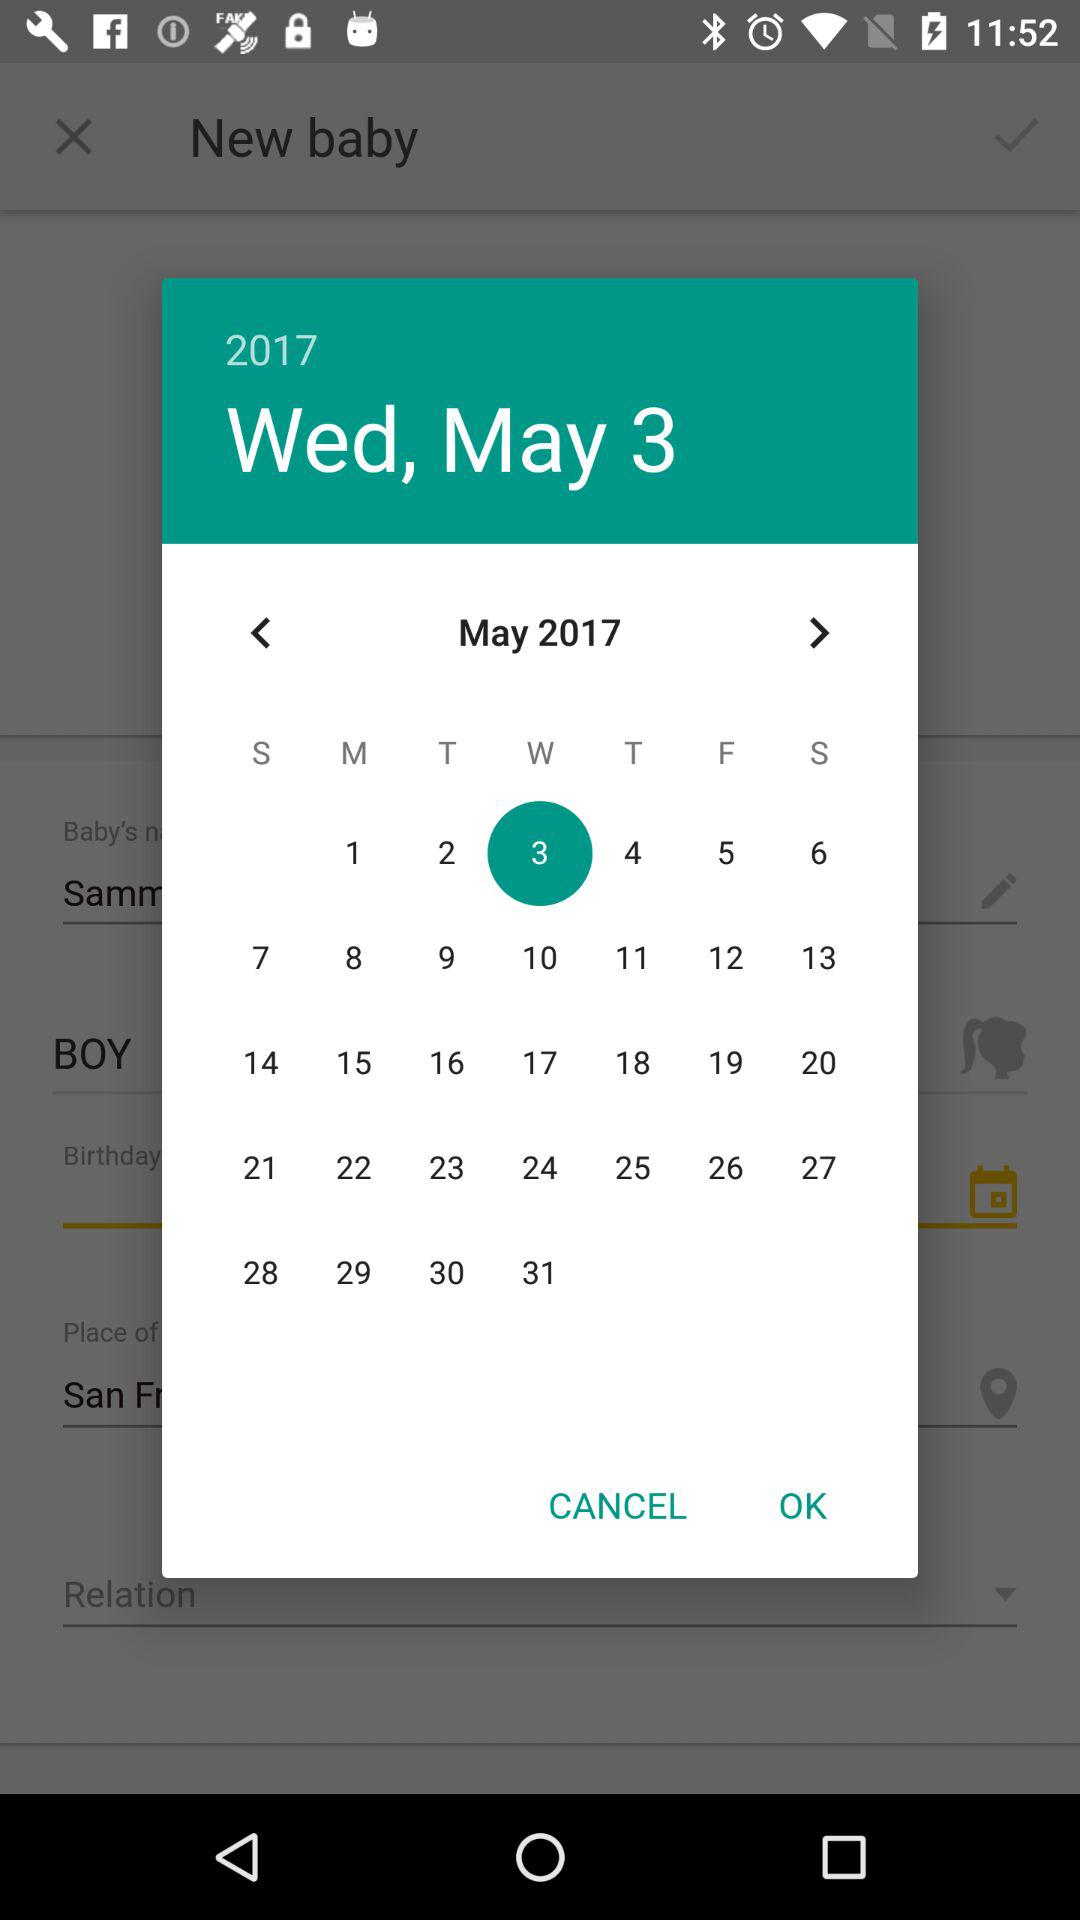Which date is selected? The selected date is Wednesday, May 3, 2017. 